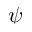<formula> <loc_0><loc_0><loc_500><loc_500>\psi</formula> 